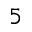Convert formula to latex. <formula><loc_0><loc_0><loc_500><loc_500>5</formula> 